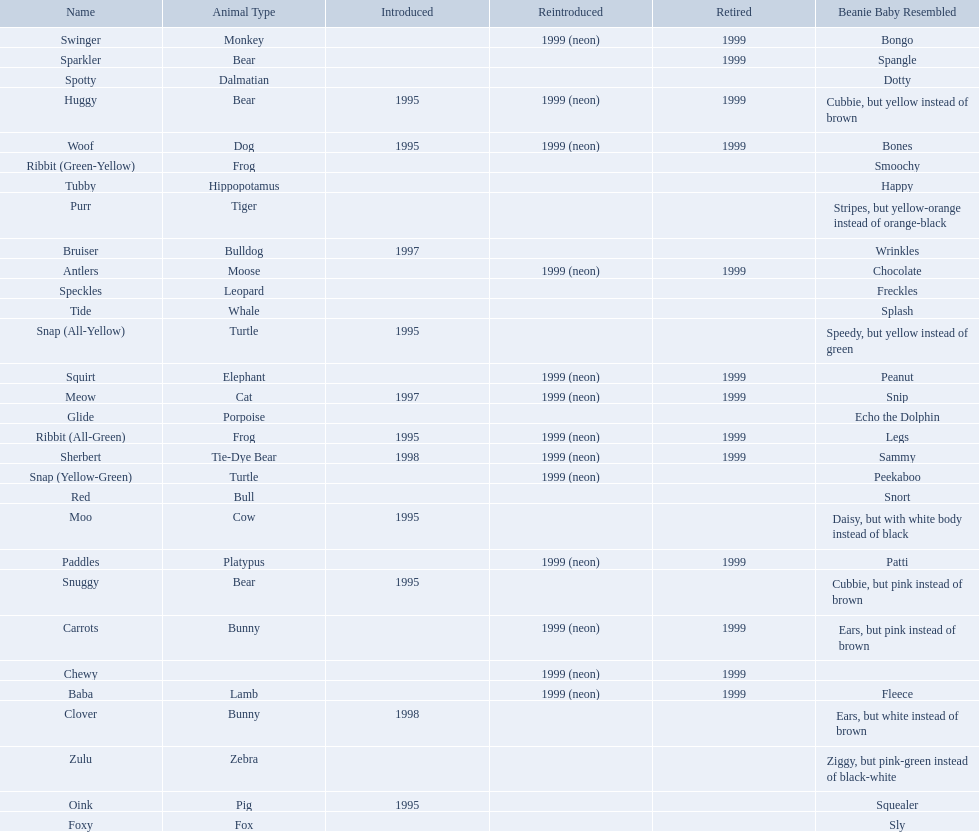What are all the pillow pals? Antlers, Baba, Bruiser, Carrots, Chewy, Clover, Foxy, Glide, Huggy, Meow, Moo, Oink, Paddles, Purr, Red, Ribbit (All-Green), Ribbit (Green-Yellow), Sherbert, Snap (All-Yellow), Snap (Yellow-Green), Snuggy, Sparkler, Speckles, Spotty, Squirt, Swinger, Tide, Tubby, Woof, Zulu. Which is the only without a listed animal type? Chewy. 